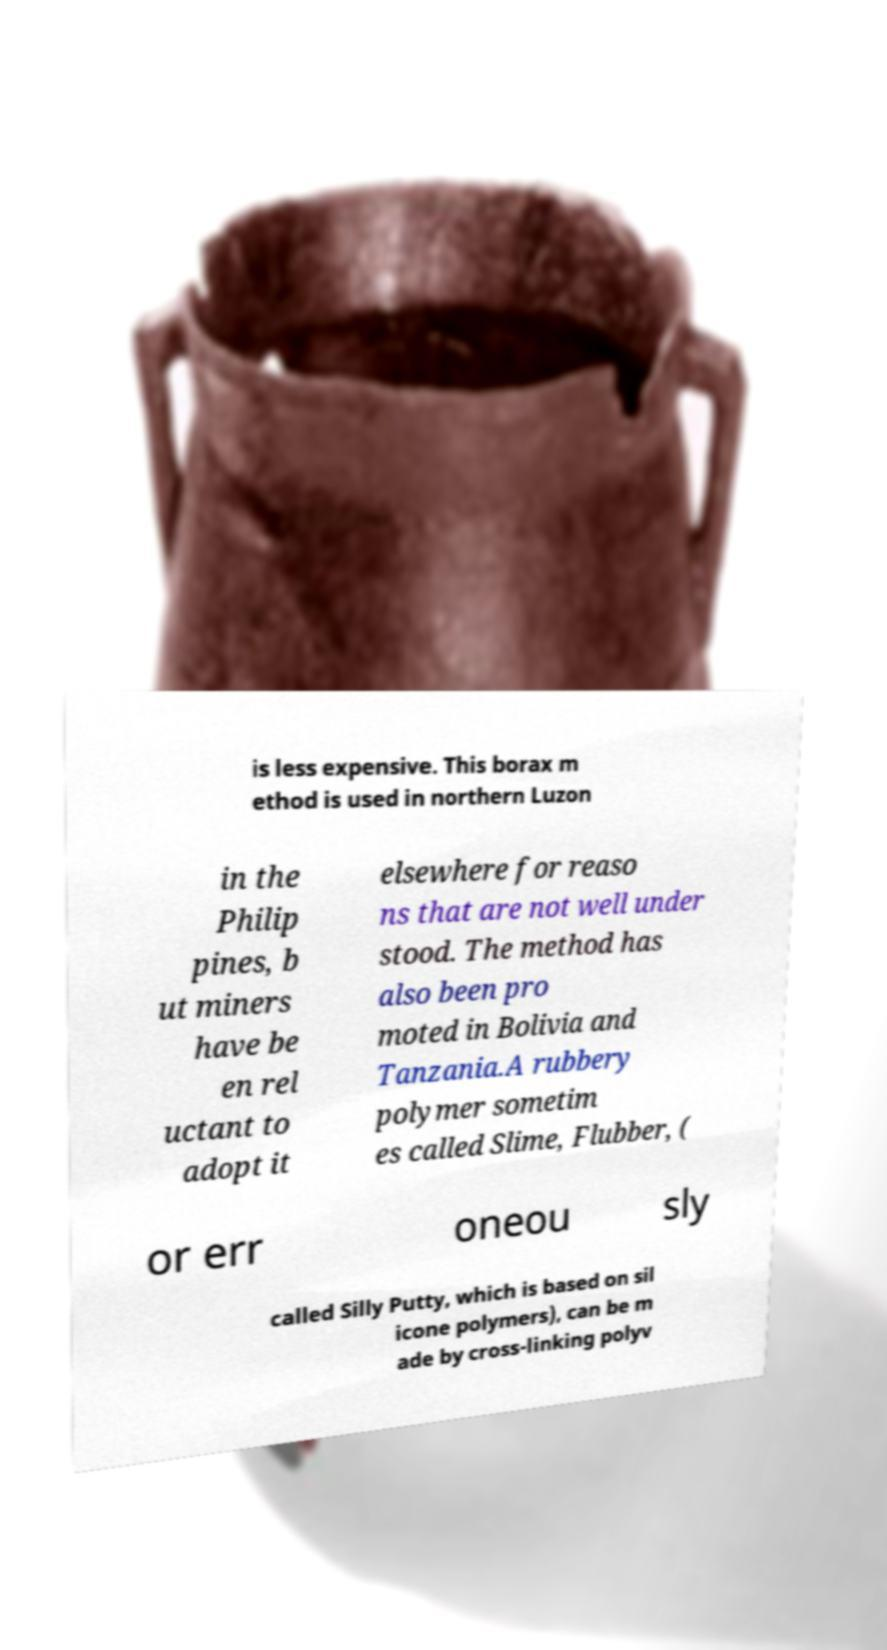I need the written content from this picture converted into text. Can you do that? is less expensive. This borax m ethod is used in northern Luzon in the Philip pines, b ut miners have be en rel uctant to adopt it elsewhere for reaso ns that are not well under stood. The method has also been pro moted in Bolivia and Tanzania.A rubbery polymer sometim es called Slime, Flubber, ( or err oneou sly called Silly Putty, which is based on sil icone polymers), can be m ade by cross-linking polyv 